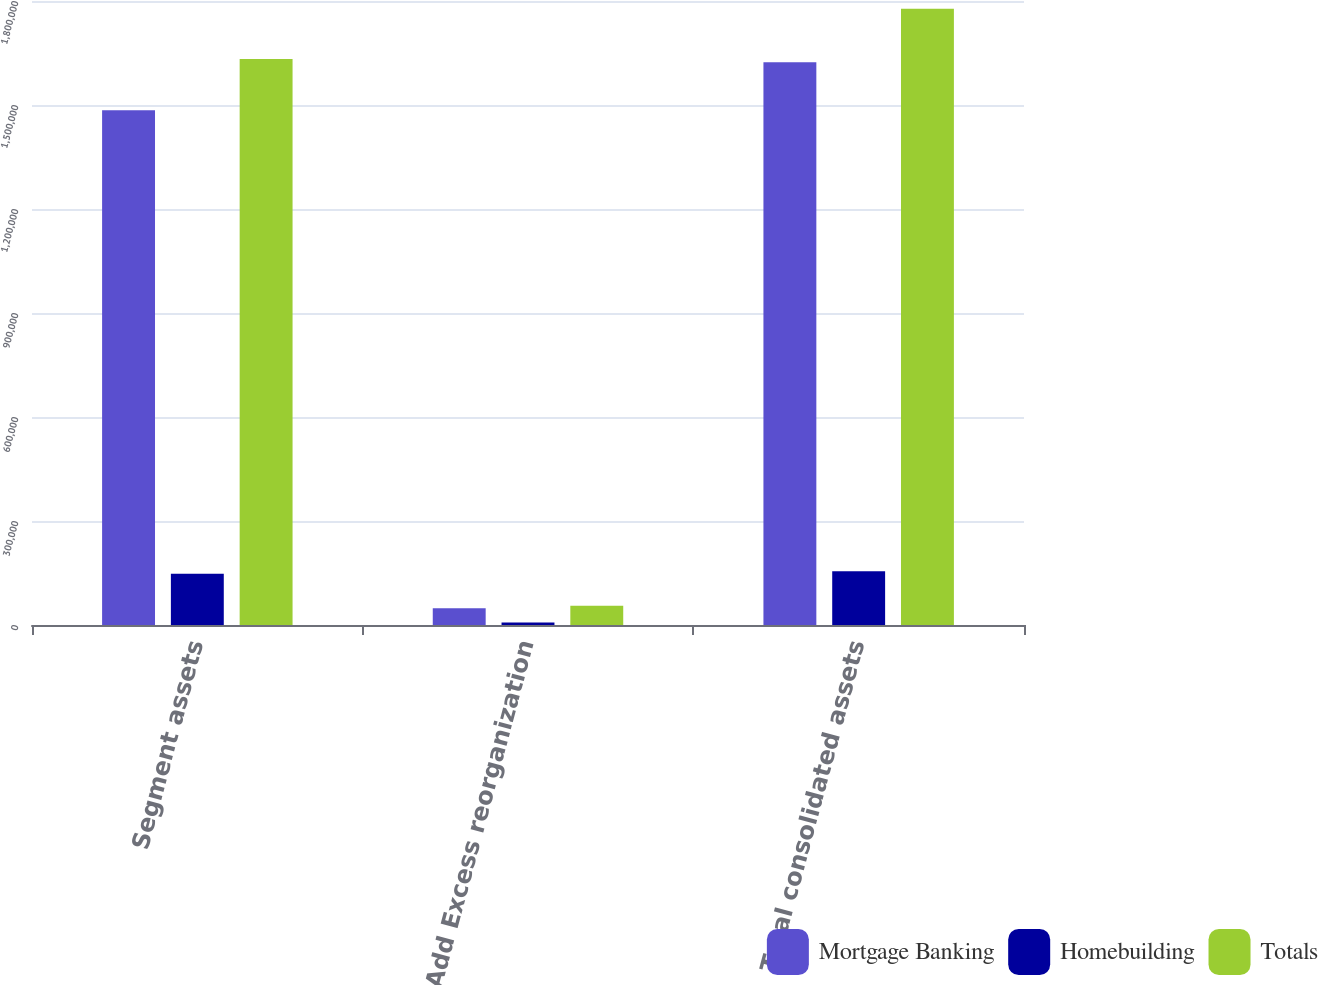Convert chart. <chart><loc_0><loc_0><loc_500><loc_500><stacked_bar_chart><ecel><fcel>Segment assets<fcel>Add Excess reorganization<fcel>Total consolidated assets<nl><fcel>Mortgage Banking<fcel>1.48508e+06<fcel>47959<fcel>1.62297e+06<nl><fcel>Homebuilding<fcel>147652<fcel>7347<fcel>154999<nl><fcel>Totals<fcel>1.63274e+06<fcel>55306<fcel>1.77797e+06<nl></chart> 